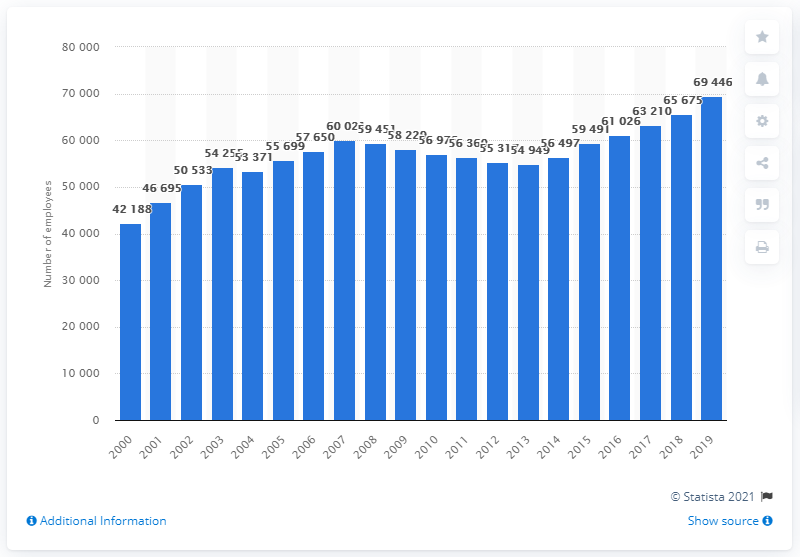Point out several critical features in this image. In 2019, a total of 69,446 people were employed in hospitals in Ireland. 